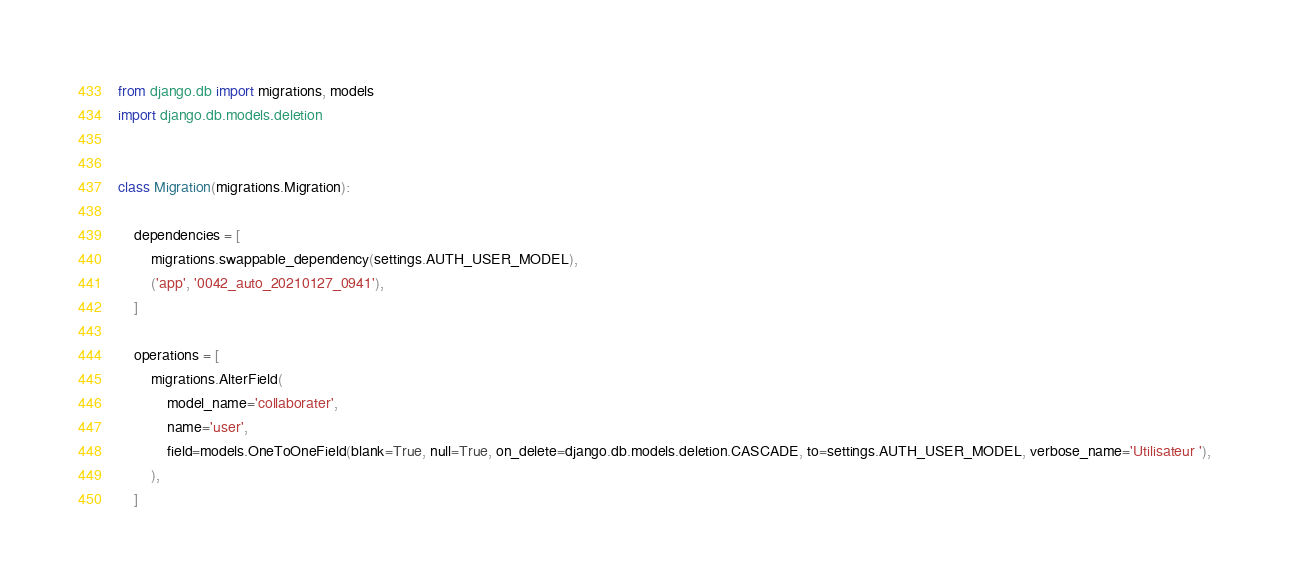Convert code to text. <code><loc_0><loc_0><loc_500><loc_500><_Python_>from django.db import migrations, models
import django.db.models.deletion


class Migration(migrations.Migration):

    dependencies = [
        migrations.swappable_dependency(settings.AUTH_USER_MODEL),
        ('app', '0042_auto_20210127_0941'),
    ]

    operations = [
        migrations.AlterField(
            model_name='collaborater',
            name='user',
            field=models.OneToOneField(blank=True, null=True, on_delete=django.db.models.deletion.CASCADE, to=settings.AUTH_USER_MODEL, verbose_name='Utilisateur '),
        ),
    ]
</code> 